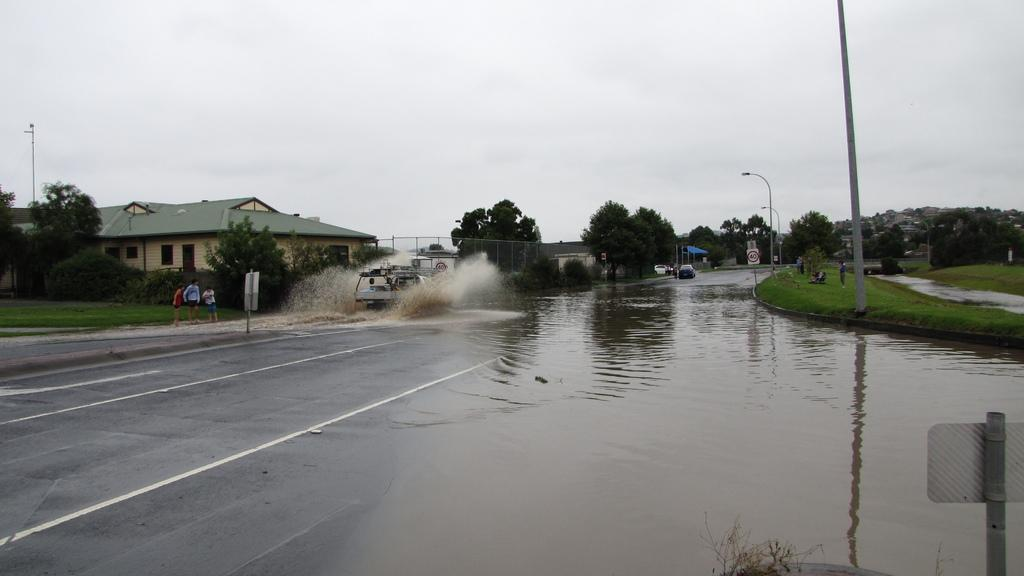What is on the road in the image? There is water on the road in the image. Who or what can be seen in the image? There are people and vehicles in the image. What else is present in the image besides people and vehicles? There are trees, buildings, poles, lights, and sign boards in the image. What can be seen in the background of the image? The sky is visible in the background of the image. How many cushions are floating on the water in the image? There are no cushions present in the image; it features water on the road. What type of boats can be seen in the image? There are no boats present in the image; it features water on the road, people, vehicles, trees, buildings, poles, lights, and sign boards. 